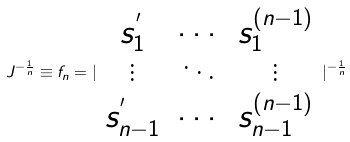<formula> <loc_0><loc_0><loc_500><loc_500>J ^ { - \frac { 1 } { n } } \equiv f _ { n } = | \begin{array} { c c c } s _ { 1 } ^ { ^ { \prime } } & \cdots & s _ { 1 } ^ { ( n - 1 ) } \\ \vdots & \ddots & \vdots \\ s _ { n - 1 } ^ { ^ { \prime } } & \cdots & s _ { n - 1 } ^ { ( n - 1 ) } \end{array} | ^ { - \frac { 1 } { n } }</formula> 